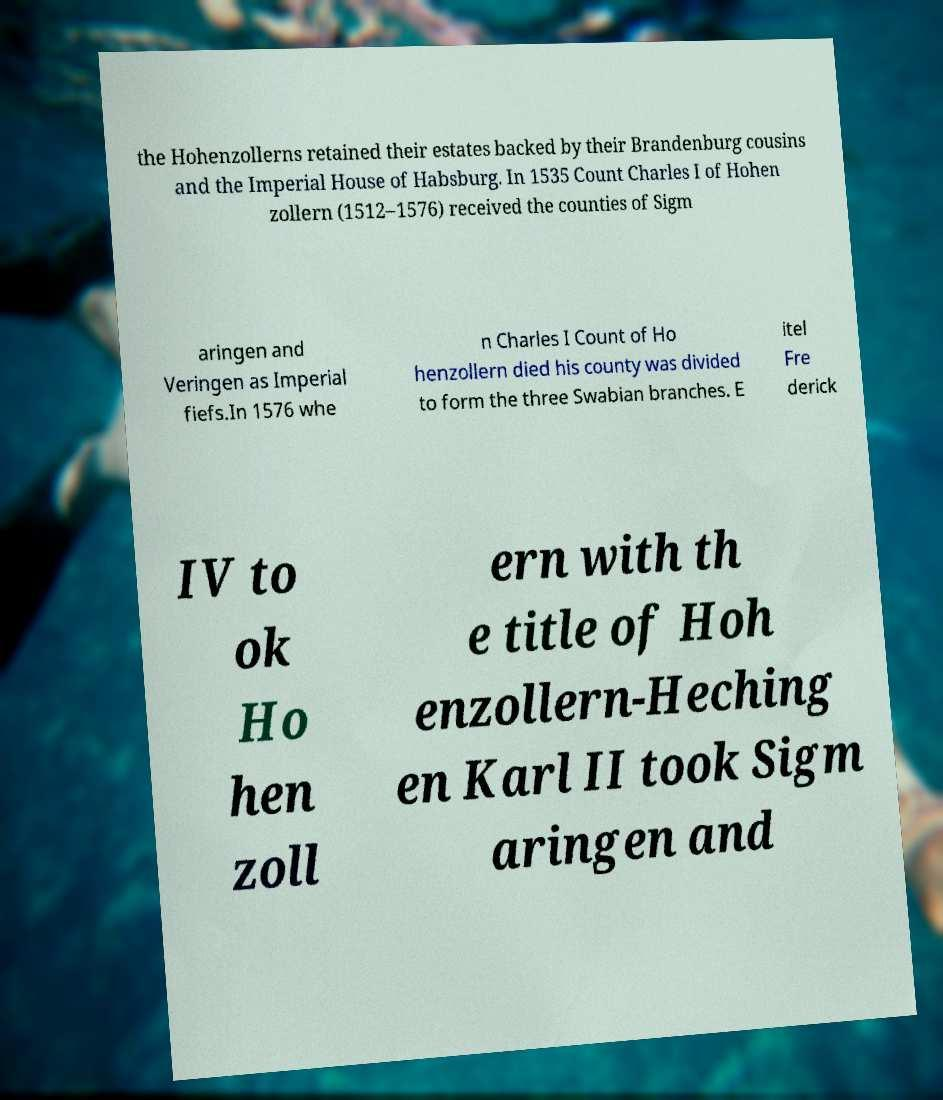Can you accurately transcribe the text from the provided image for me? the Hohenzollerns retained their estates backed by their Brandenburg cousins and the Imperial House of Habsburg. In 1535 Count Charles I of Hohen zollern (1512–1576) received the counties of Sigm aringen and Veringen as Imperial fiefs.In 1576 whe n Charles I Count of Ho henzollern died his county was divided to form the three Swabian branches. E itel Fre derick IV to ok Ho hen zoll ern with th e title of Hoh enzollern-Heching en Karl II took Sigm aringen and 